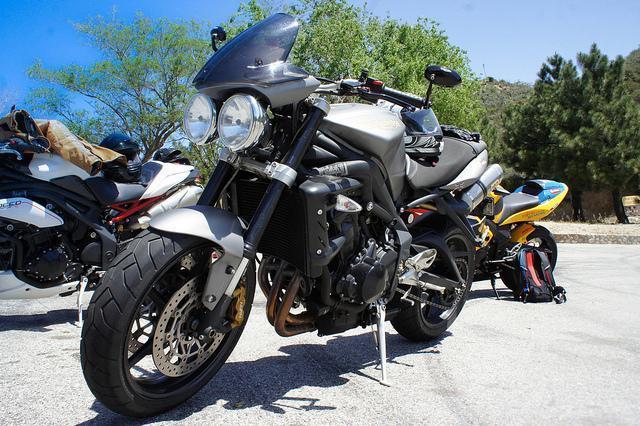How many motorcycles are in the picture?
Give a very brief answer. 3. How many people are holding a wine glass?
Give a very brief answer. 0. 